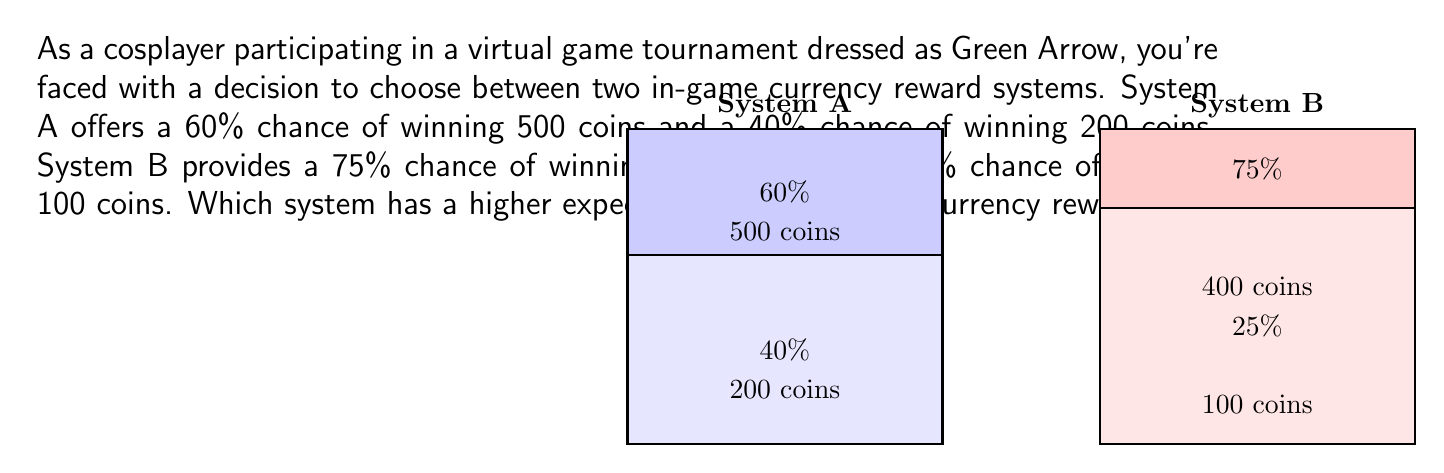Can you answer this question? To solve this problem, we need to calculate the expected value for each system and compare them:

1. Expected Value of System A:
   Let $E(A)$ be the expected value of System A.
   $$E(A) = 0.60 \times 500 + 0.40 \times 200$$
   $$E(A) = 300 + 80 = 380\text{ coins}$$

2. Expected Value of System B:
   Let $E(B)$ be the expected value of System B.
   $$E(B) = 0.75 \times 400 + 0.25 \times 100$$
   $$E(B) = 300 + 25 = 325\text{ coins}$$

3. Comparison:
   $E(A) = 380\text{ coins} > E(B) = 325\text{ coins}$

Therefore, System A has a higher expected value of in-game currency rewards.
Answer: $380\text{ coins}$ (System A) 